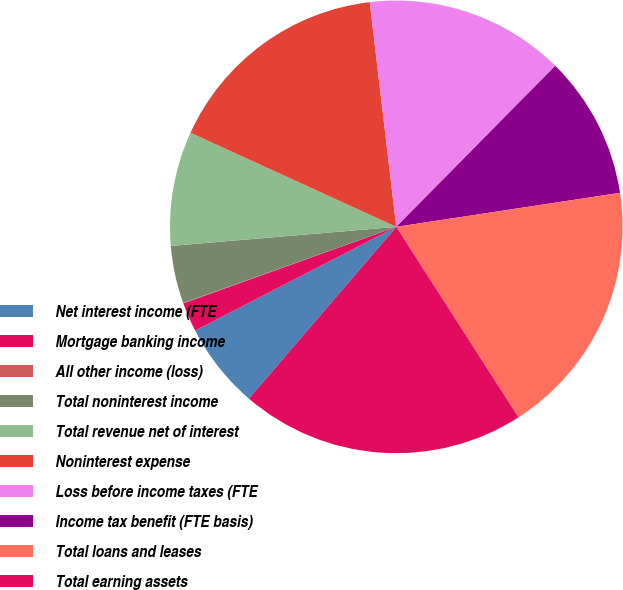Convert chart. <chart><loc_0><loc_0><loc_500><loc_500><pie_chart><fcel>Net interest income (FTE<fcel>Mortgage banking income<fcel>All other income (loss)<fcel>Total noninterest income<fcel>Total revenue net of interest<fcel>Noninterest expense<fcel>Loss before income taxes (FTE<fcel>Income tax benefit (FTE basis)<fcel>Total loans and leases<fcel>Total earning assets<nl><fcel>6.14%<fcel>2.08%<fcel>0.04%<fcel>4.11%<fcel>8.17%<fcel>16.3%<fcel>14.27%<fcel>10.2%<fcel>18.33%<fcel>20.36%<nl></chart> 